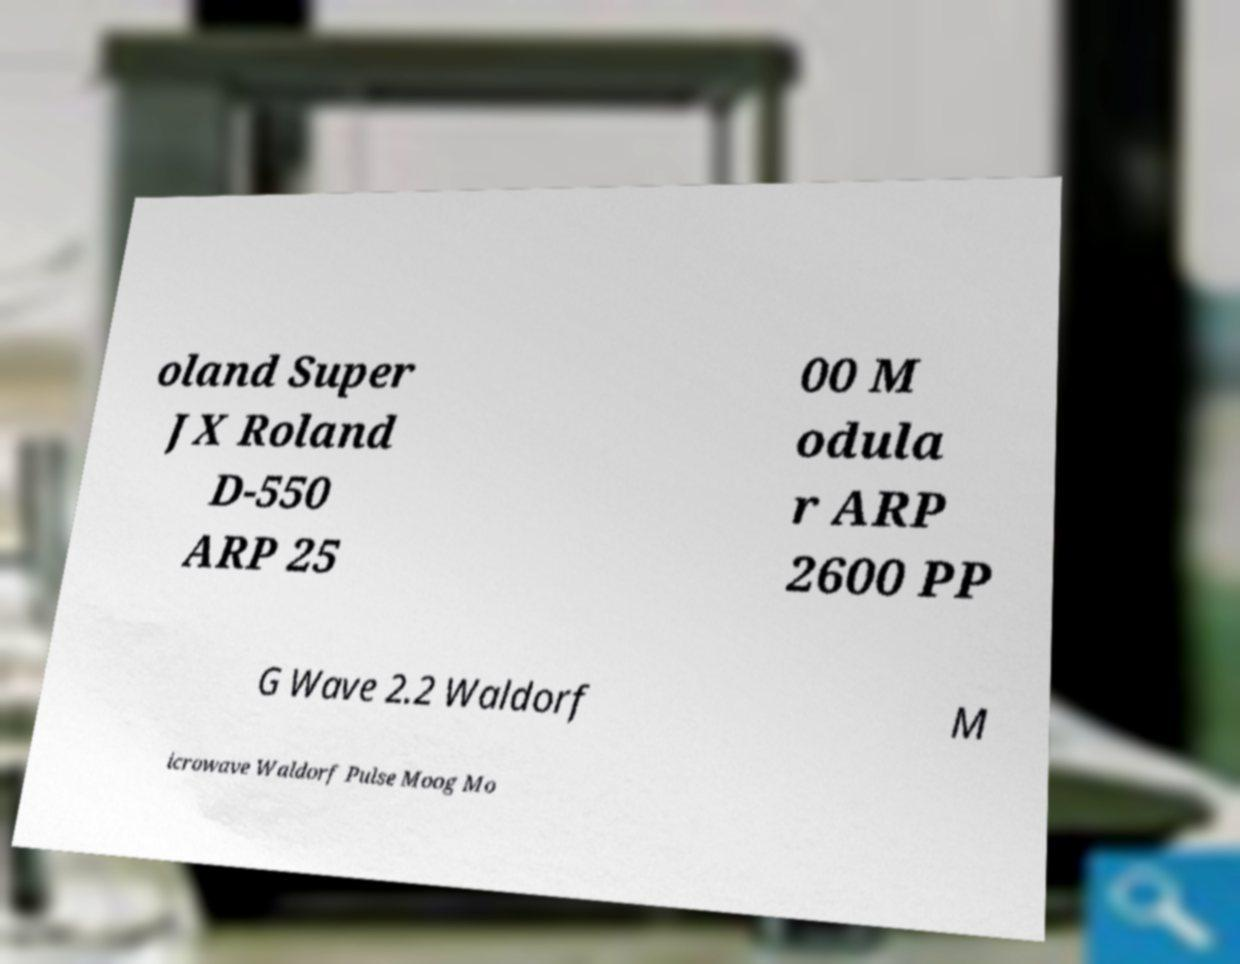What messages or text are displayed in this image? I need them in a readable, typed format. oland Super JX Roland D-550 ARP 25 00 M odula r ARP 2600 PP G Wave 2.2 Waldorf M icrowave Waldorf Pulse Moog Mo 